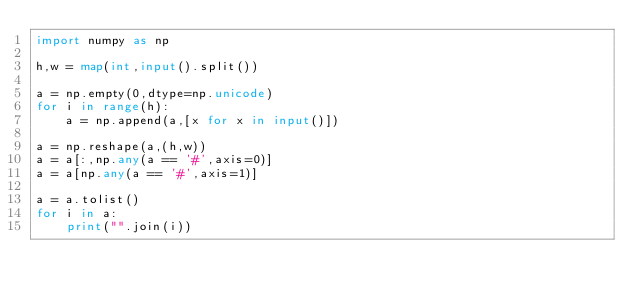<code> <loc_0><loc_0><loc_500><loc_500><_Python_>import numpy as np

h,w = map(int,input().split())

a = np.empty(0,dtype=np.unicode)
for i in range(h):
    a = np.append(a,[x for x in input()])

a = np.reshape(a,(h,w))
a = a[:,np.any(a == '#',axis=0)]
a = a[np.any(a == '#',axis=1)]

a = a.tolist()
for i in a:
    print("".join(i))
</code> 